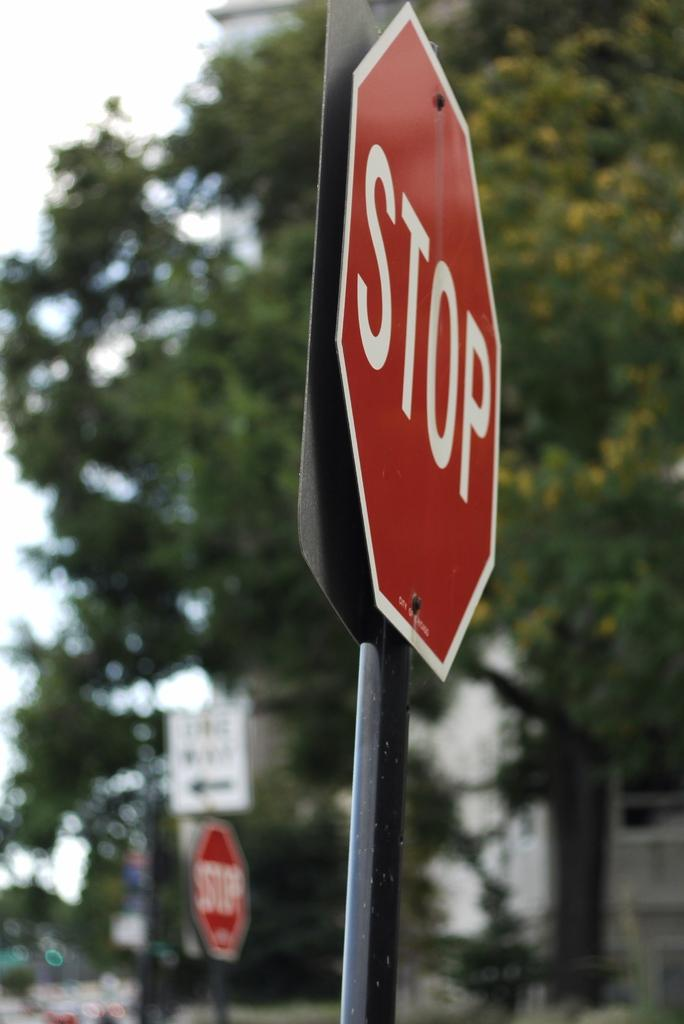<image>
Render a clear and concise summary of the photo. Two stop signs on a street corner with trees in the background. 